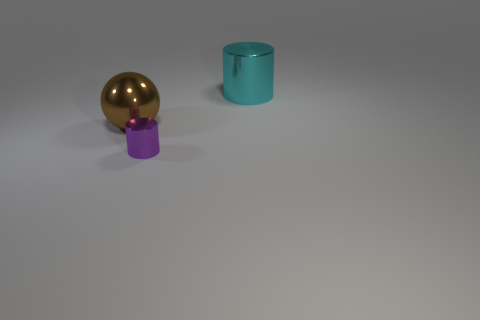What could the spatial arrangement of these objects suggest? The spatial arrangement of the objects could be interpreted in various ways. One might see it as a deliberate study in minimalism and balance, with the objects possibly representing different elements or entities in relation to one another in a sparse, open space. 